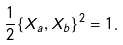Convert formula to latex. <formula><loc_0><loc_0><loc_500><loc_500>\frac { 1 } { 2 } \{ X _ { a } , X _ { b } \} ^ { 2 } = 1 .</formula> 